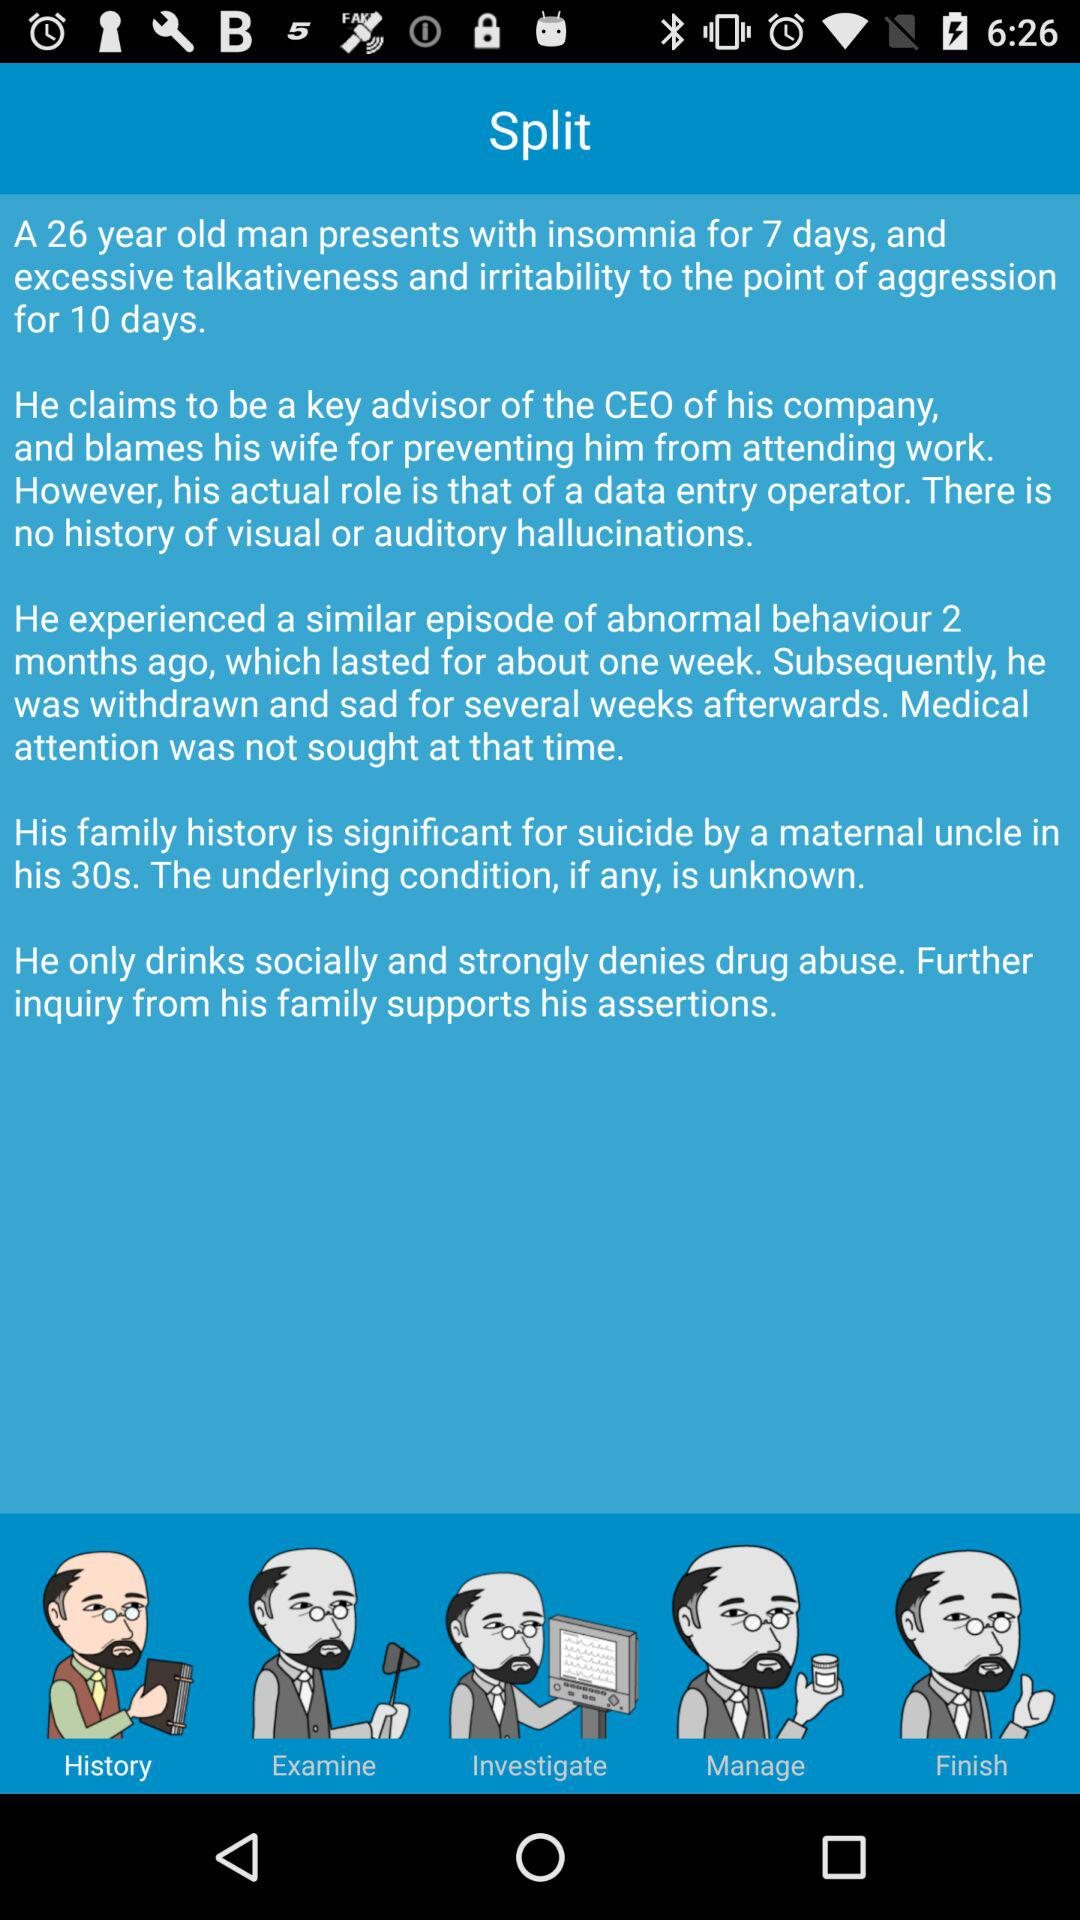What is the age of the man? The age of the man is 26. 